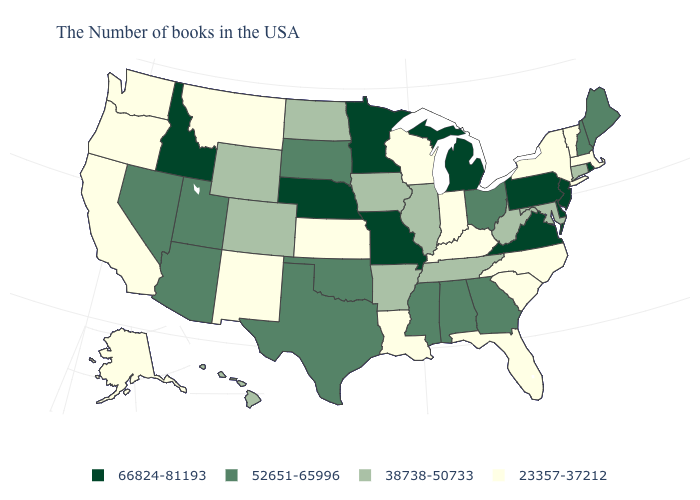What is the value of Wyoming?
Quick response, please. 38738-50733. What is the value of Vermont?
Give a very brief answer. 23357-37212. Which states have the lowest value in the South?
Be succinct. North Carolina, South Carolina, Florida, Kentucky, Louisiana. Which states have the highest value in the USA?
Write a very short answer. Rhode Island, New Jersey, Delaware, Pennsylvania, Virginia, Michigan, Missouri, Minnesota, Nebraska, Idaho. Does Hawaii have the same value as Montana?
Answer briefly. No. How many symbols are there in the legend?
Write a very short answer. 4. What is the value of Colorado?
Give a very brief answer. 38738-50733. Does the map have missing data?
Answer briefly. No. Name the states that have a value in the range 38738-50733?
Short answer required. Connecticut, Maryland, West Virginia, Tennessee, Illinois, Arkansas, Iowa, North Dakota, Wyoming, Colorado, Hawaii. Does the first symbol in the legend represent the smallest category?
Short answer required. No. Which states hav the highest value in the South?
Concise answer only. Delaware, Virginia. What is the highest value in the MidWest ?
Answer briefly. 66824-81193. What is the highest value in the MidWest ?
Answer briefly. 66824-81193. What is the highest value in the Northeast ?
Quick response, please. 66824-81193. Among the states that border Florida , which have the lowest value?
Short answer required. Georgia, Alabama. 